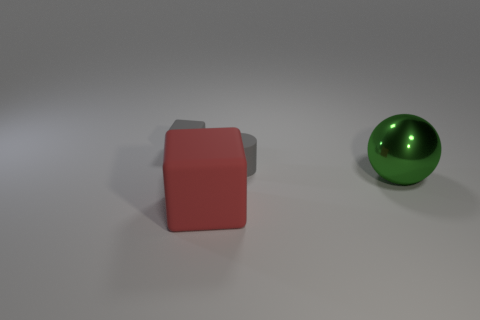Add 3 green spheres. How many objects exist? 7 Subtract all spheres. How many objects are left? 3 Subtract all big red rubber blocks. Subtract all small gray cylinders. How many objects are left? 2 Add 1 small cylinders. How many small cylinders are left? 2 Add 2 big green shiny balls. How many big green shiny balls exist? 3 Subtract 0 purple cylinders. How many objects are left? 4 